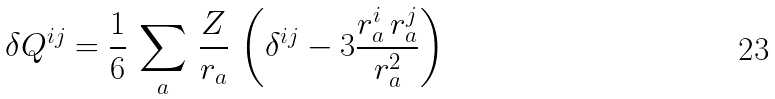Convert formula to latex. <formula><loc_0><loc_0><loc_500><loc_500>\delta Q ^ { i j } = \frac { 1 } { 6 } \, \sum _ { a } \, \frac { Z } { r _ { a } } \, \left ( \delta ^ { i j } - 3 \frac { r _ { a } ^ { i } \, r _ { a } ^ { j } } { r _ { a } ^ { 2 } } \right ) \,</formula> 